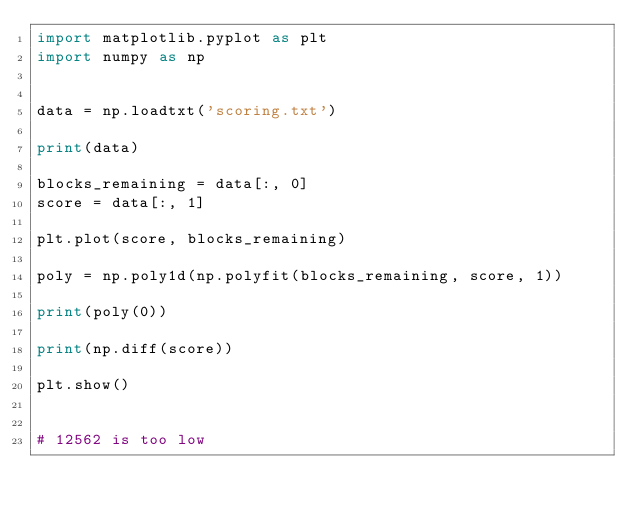Convert code to text. <code><loc_0><loc_0><loc_500><loc_500><_Python_>import matplotlib.pyplot as plt
import numpy as np


data = np.loadtxt('scoring.txt')

print(data)

blocks_remaining = data[:, 0]
score = data[:, 1]

plt.plot(score, blocks_remaining)

poly = np.poly1d(np.polyfit(blocks_remaining, score, 1))

print(poly(0))

print(np.diff(score))

plt.show()


# 12562 is too low</code> 